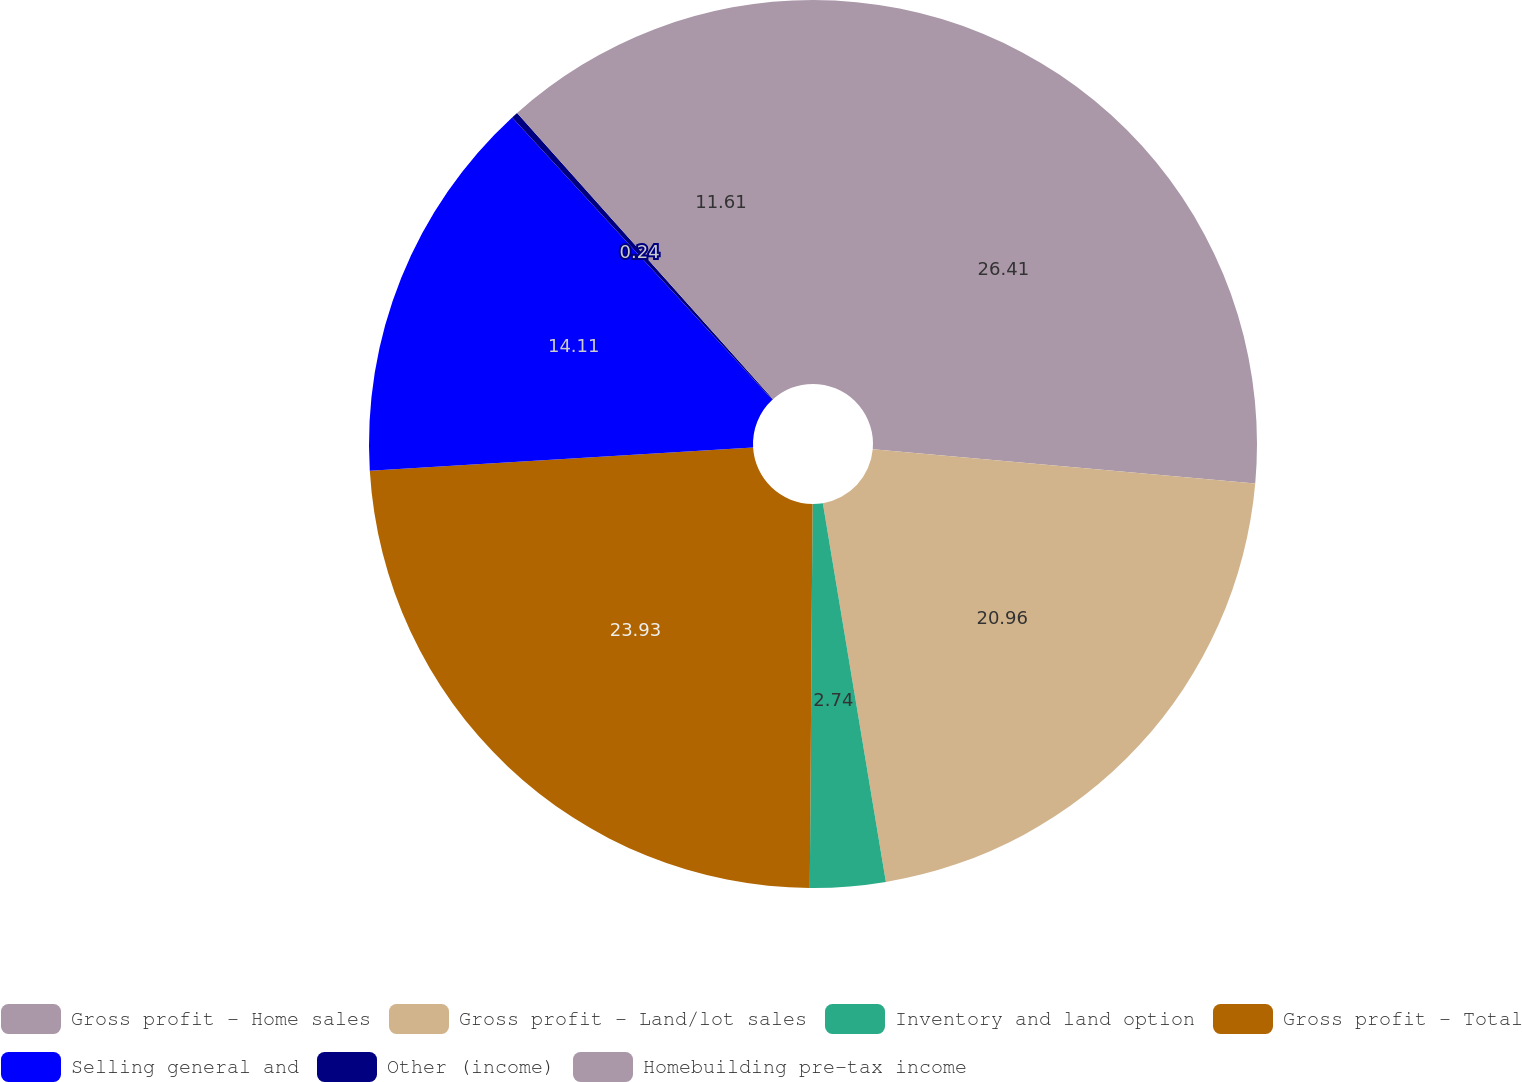Convert chart. <chart><loc_0><loc_0><loc_500><loc_500><pie_chart><fcel>Gross profit - Home sales<fcel>Gross profit - Land/lot sales<fcel>Inventory and land option<fcel>Gross profit - Total<fcel>Selling general and<fcel>Other (income)<fcel>Homebuilding pre-tax income<nl><fcel>26.42%<fcel>20.96%<fcel>2.74%<fcel>23.93%<fcel>14.11%<fcel>0.24%<fcel>11.61%<nl></chart> 